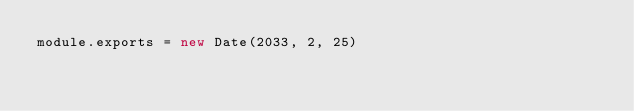Convert code to text. <code><loc_0><loc_0><loc_500><loc_500><_JavaScript_>module.exports = new Date(2033, 2, 25)
</code> 